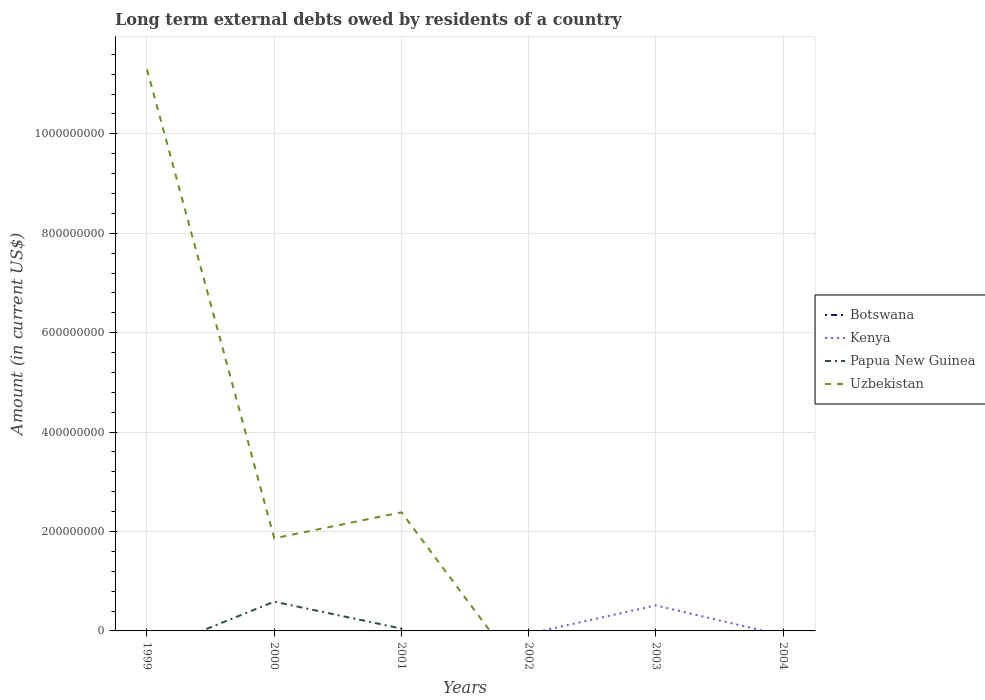How many different coloured lines are there?
Your response must be concise. 3. Does the line corresponding to Papua New Guinea intersect with the line corresponding to Kenya?
Make the answer very short. Yes. Is the number of lines equal to the number of legend labels?
Offer a very short reply. No. Across all years, what is the maximum amount of long-term external debts owed by residents in Kenya?
Your answer should be very brief. 0. What is the total amount of long-term external debts owed by residents in Uzbekistan in the graph?
Keep it short and to the point. -5.22e+07. What is the difference between the highest and the second highest amount of long-term external debts owed by residents in Kenya?
Give a very brief answer. 5.14e+07. What is the difference between the highest and the lowest amount of long-term external debts owed by residents in Kenya?
Your answer should be compact. 1. Are the values on the major ticks of Y-axis written in scientific E-notation?
Provide a short and direct response. No. Does the graph contain any zero values?
Provide a succinct answer. Yes. Does the graph contain grids?
Your answer should be compact. Yes. Where does the legend appear in the graph?
Provide a short and direct response. Center right. What is the title of the graph?
Keep it short and to the point. Long term external debts owed by residents of a country. Does "Armenia" appear as one of the legend labels in the graph?
Provide a short and direct response. No. What is the label or title of the X-axis?
Your answer should be compact. Years. What is the Amount (in current US$) of Botswana in 1999?
Offer a terse response. 0. What is the Amount (in current US$) of Papua New Guinea in 1999?
Provide a short and direct response. 0. What is the Amount (in current US$) in Uzbekistan in 1999?
Your answer should be very brief. 1.13e+09. What is the Amount (in current US$) in Papua New Guinea in 2000?
Offer a very short reply. 5.89e+07. What is the Amount (in current US$) of Uzbekistan in 2000?
Offer a terse response. 1.86e+08. What is the Amount (in current US$) in Kenya in 2001?
Your answer should be compact. 0. What is the Amount (in current US$) of Papua New Guinea in 2001?
Provide a short and direct response. 4.68e+06. What is the Amount (in current US$) of Uzbekistan in 2001?
Give a very brief answer. 2.39e+08. What is the Amount (in current US$) of Kenya in 2002?
Offer a terse response. 0. What is the Amount (in current US$) in Kenya in 2003?
Keep it short and to the point. 5.14e+07. What is the Amount (in current US$) of Uzbekistan in 2003?
Your answer should be compact. 0. What is the Amount (in current US$) in Botswana in 2004?
Your response must be concise. 0. What is the Amount (in current US$) of Kenya in 2004?
Provide a short and direct response. 0. What is the Amount (in current US$) in Papua New Guinea in 2004?
Make the answer very short. 0. What is the Amount (in current US$) of Uzbekistan in 2004?
Offer a very short reply. 0. Across all years, what is the maximum Amount (in current US$) of Kenya?
Provide a short and direct response. 5.14e+07. Across all years, what is the maximum Amount (in current US$) in Papua New Guinea?
Your answer should be very brief. 5.89e+07. Across all years, what is the maximum Amount (in current US$) in Uzbekistan?
Offer a very short reply. 1.13e+09. Across all years, what is the minimum Amount (in current US$) in Papua New Guinea?
Keep it short and to the point. 0. Across all years, what is the minimum Amount (in current US$) in Uzbekistan?
Your answer should be compact. 0. What is the total Amount (in current US$) of Kenya in the graph?
Make the answer very short. 5.14e+07. What is the total Amount (in current US$) of Papua New Guinea in the graph?
Provide a succinct answer. 6.36e+07. What is the total Amount (in current US$) of Uzbekistan in the graph?
Offer a terse response. 1.55e+09. What is the difference between the Amount (in current US$) in Uzbekistan in 1999 and that in 2000?
Your answer should be very brief. 9.43e+08. What is the difference between the Amount (in current US$) of Uzbekistan in 1999 and that in 2001?
Provide a short and direct response. 8.91e+08. What is the difference between the Amount (in current US$) of Papua New Guinea in 2000 and that in 2001?
Your answer should be very brief. 5.42e+07. What is the difference between the Amount (in current US$) of Uzbekistan in 2000 and that in 2001?
Your response must be concise. -5.22e+07. What is the difference between the Amount (in current US$) of Papua New Guinea in 2000 and the Amount (in current US$) of Uzbekistan in 2001?
Provide a succinct answer. -1.80e+08. What is the average Amount (in current US$) of Kenya per year?
Keep it short and to the point. 8.57e+06. What is the average Amount (in current US$) in Papua New Guinea per year?
Make the answer very short. 1.06e+07. What is the average Amount (in current US$) of Uzbekistan per year?
Your answer should be very brief. 2.59e+08. In the year 2000, what is the difference between the Amount (in current US$) of Papua New Guinea and Amount (in current US$) of Uzbekistan?
Make the answer very short. -1.27e+08. In the year 2001, what is the difference between the Amount (in current US$) in Papua New Guinea and Amount (in current US$) in Uzbekistan?
Keep it short and to the point. -2.34e+08. What is the ratio of the Amount (in current US$) of Uzbekistan in 1999 to that in 2000?
Give a very brief answer. 6.06. What is the ratio of the Amount (in current US$) in Uzbekistan in 1999 to that in 2001?
Ensure brevity in your answer.  4.73. What is the ratio of the Amount (in current US$) of Papua New Guinea in 2000 to that in 2001?
Give a very brief answer. 12.57. What is the ratio of the Amount (in current US$) of Uzbekistan in 2000 to that in 2001?
Provide a short and direct response. 0.78. What is the difference between the highest and the second highest Amount (in current US$) of Uzbekistan?
Ensure brevity in your answer.  8.91e+08. What is the difference between the highest and the lowest Amount (in current US$) in Kenya?
Make the answer very short. 5.14e+07. What is the difference between the highest and the lowest Amount (in current US$) in Papua New Guinea?
Your answer should be compact. 5.89e+07. What is the difference between the highest and the lowest Amount (in current US$) of Uzbekistan?
Offer a terse response. 1.13e+09. 